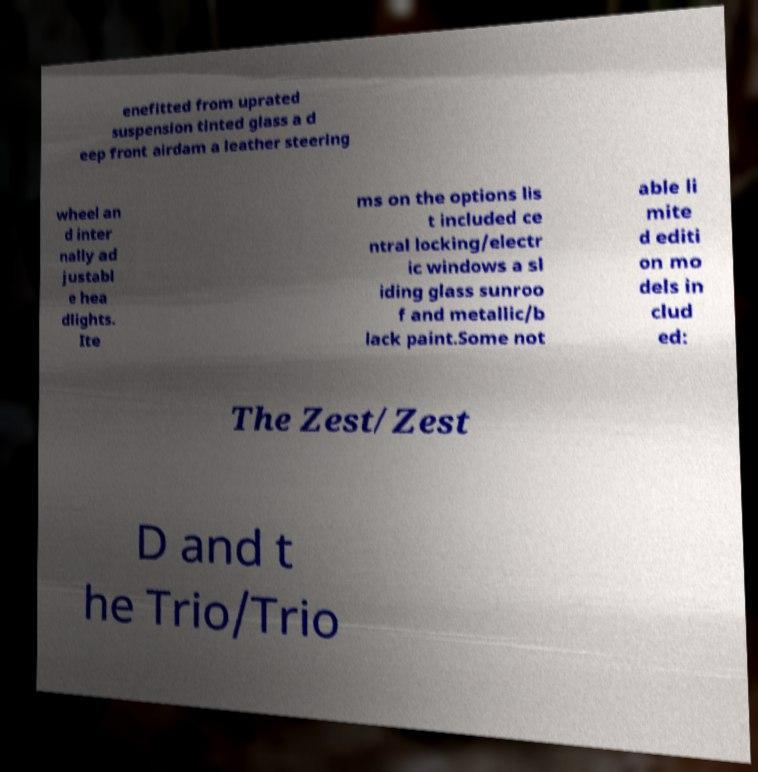Could you assist in decoding the text presented in this image and type it out clearly? enefitted from uprated suspension tinted glass a d eep front airdam a leather steering wheel an d inter nally ad justabl e hea dlights. Ite ms on the options lis t included ce ntral locking/electr ic windows a sl iding glass sunroo f and metallic/b lack paint.Some not able li mite d editi on mo dels in clud ed: The Zest/Zest D and t he Trio/Trio 